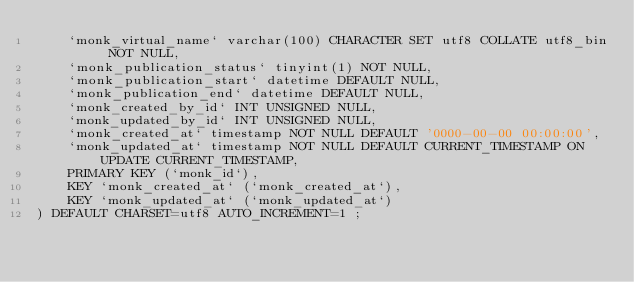<code> <loc_0><loc_0><loc_500><loc_500><_SQL_>    `monk_virtual_name` varchar(100) CHARACTER SET utf8 COLLATE utf8_bin NOT NULL,
    `monk_publication_status` tinyint(1) NOT NULL,
    `monk_publication_start` datetime DEFAULT NULL,
    `monk_publication_end` datetime DEFAULT NULL,
    `monk_created_by_id` INT UNSIGNED NULL,
    `monk_updated_by_id` INT UNSIGNED NULL,
    `monk_created_at` timestamp NOT NULL DEFAULT '0000-00-00 00:00:00',
    `monk_updated_at` timestamp NOT NULL DEFAULT CURRENT_TIMESTAMP ON UPDATE CURRENT_TIMESTAMP,
    PRIMARY KEY (`monk_id`),
    KEY `monk_created_at` (`monk_created_at`),
    KEY `monk_updated_at` (`monk_updated_at`)
) DEFAULT CHARSET=utf8 AUTO_INCREMENT=1 ;
</code> 